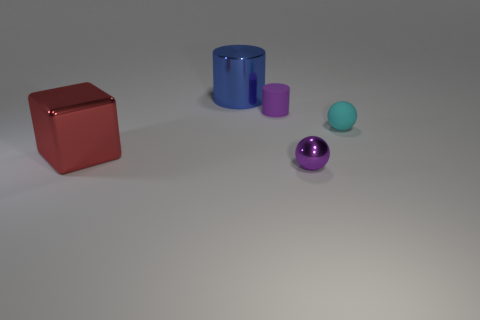Add 3 spheres. How many objects exist? 8 Subtract all blocks. How many objects are left? 4 Add 5 big yellow shiny balls. How many big yellow shiny balls exist? 5 Subtract 0 gray cylinders. How many objects are left? 5 Subtract all purple balls. Subtract all tiny purple shiny spheres. How many objects are left? 3 Add 4 cyan rubber objects. How many cyan rubber objects are left? 5 